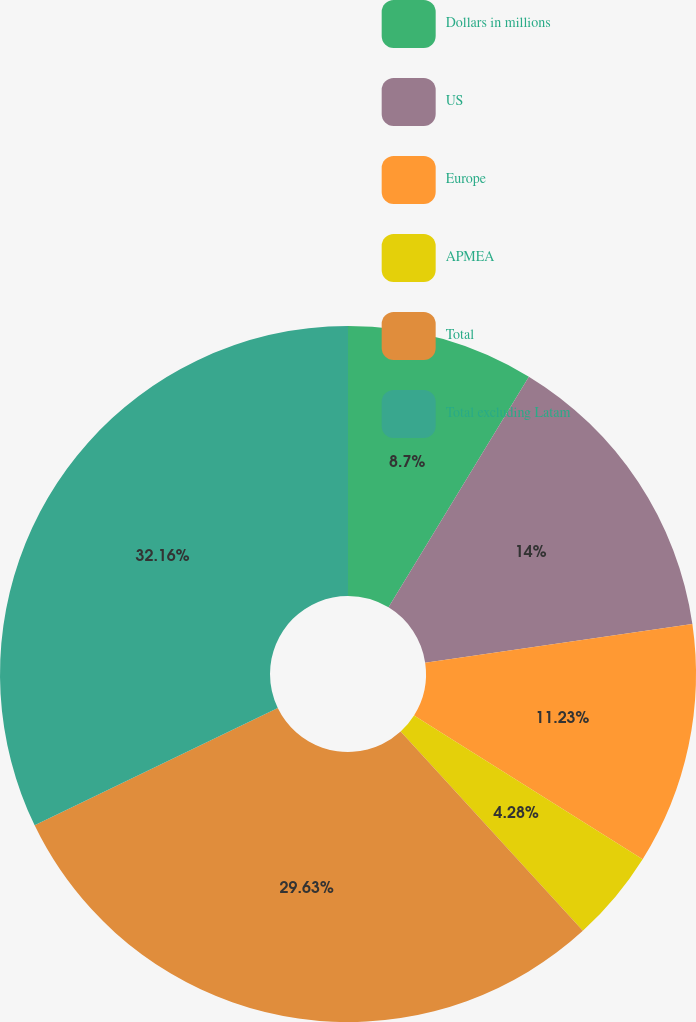Convert chart. <chart><loc_0><loc_0><loc_500><loc_500><pie_chart><fcel>Dollars in millions<fcel>US<fcel>Europe<fcel>APMEA<fcel>Total<fcel>Total excluding Latam<nl><fcel>8.7%<fcel>14.0%<fcel>11.23%<fcel>4.28%<fcel>29.63%<fcel>32.16%<nl></chart> 